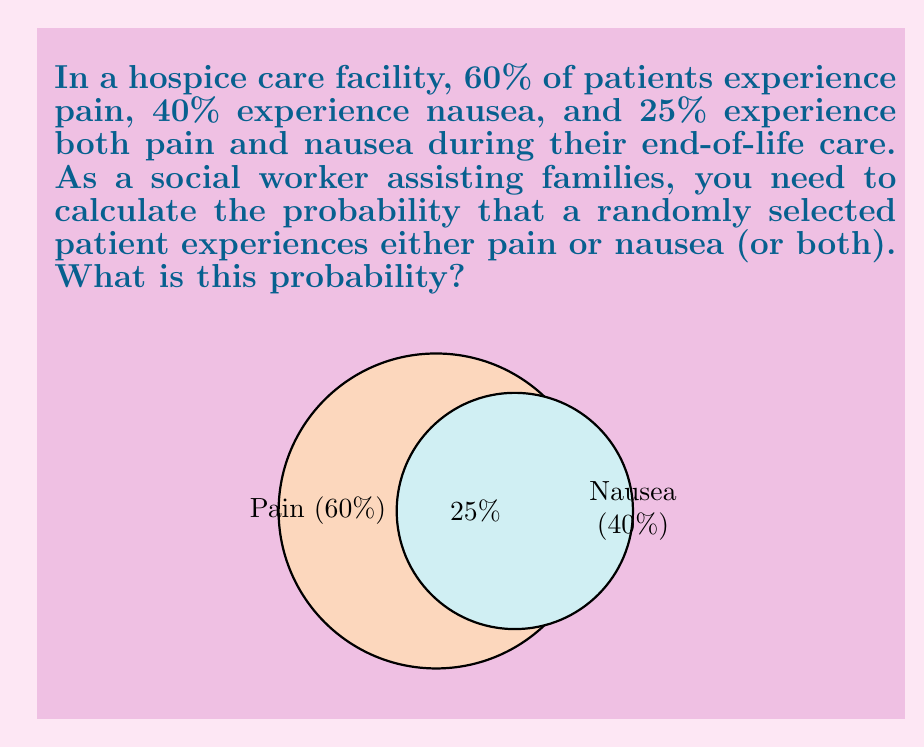Provide a solution to this math problem. To solve this problem, we can use the concept of probability for the union of two events. Let's break it down step-by-step:

1) Let A be the event of experiencing pain, and B be the event of experiencing nausea.

2) We're given:
   P(A) = 60% = 0.60
   P(B) = 40% = 0.40
   P(A ∩ B) = 25% = 0.25

3) We need to find P(A ∪ B), which is the probability of experiencing either pain or nausea or both.

4) The formula for the probability of the union of two events is:

   $$ P(A \cup B) = P(A) + P(B) - P(A \cap B) $$

5) Substituting the values:

   $$ P(A \cup B) = 0.60 + 0.40 - 0.25 $$

6) Calculating:

   $$ P(A \cup B) = 1.00 - 0.25 = 0.75 $$

7) Converting to a percentage:

   0.75 * 100% = 75%

Therefore, the probability that a randomly selected patient experiences either pain or nausea (or both) is 75%.
Answer: 75% 